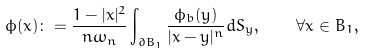Convert formula to latex. <formula><loc_0><loc_0><loc_500><loc_500>\phi ( x ) \colon = \frac { 1 - | x | ^ { 2 } } { n \omega _ { n } } \int _ { \partial B _ { 1 } } \frac { \phi _ { b } ( y ) } { | x - y | ^ { n } } d S _ { y } , \quad \forall x \in B _ { 1 } ,</formula> 